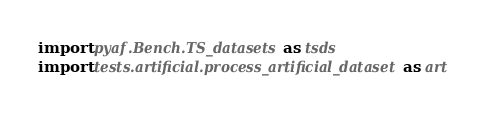Convert code to text. <code><loc_0><loc_0><loc_500><loc_500><_Python_>import pyaf.Bench.TS_datasets as tsds
import tests.artificial.process_artificial_dataset as art



</code> 